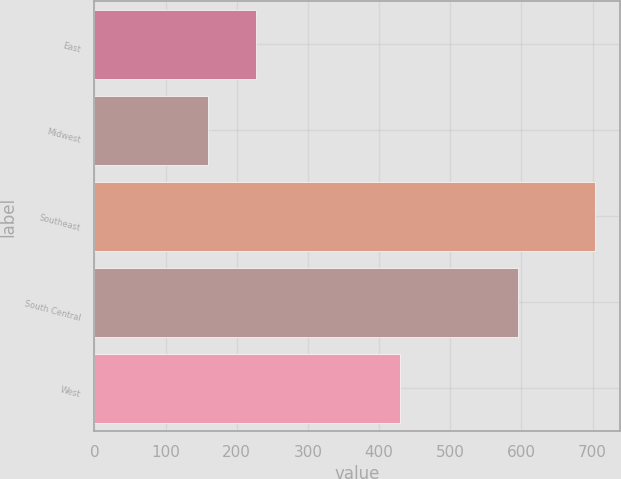<chart> <loc_0><loc_0><loc_500><loc_500><bar_chart><fcel>East<fcel>Midwest<fcel>Southeast<fcel>South Central<fcel>West<nl><fcel>226.3<fcel>159.4<fcel>703.7<fcel>595.8<fcel>428.8<nl></chart> 